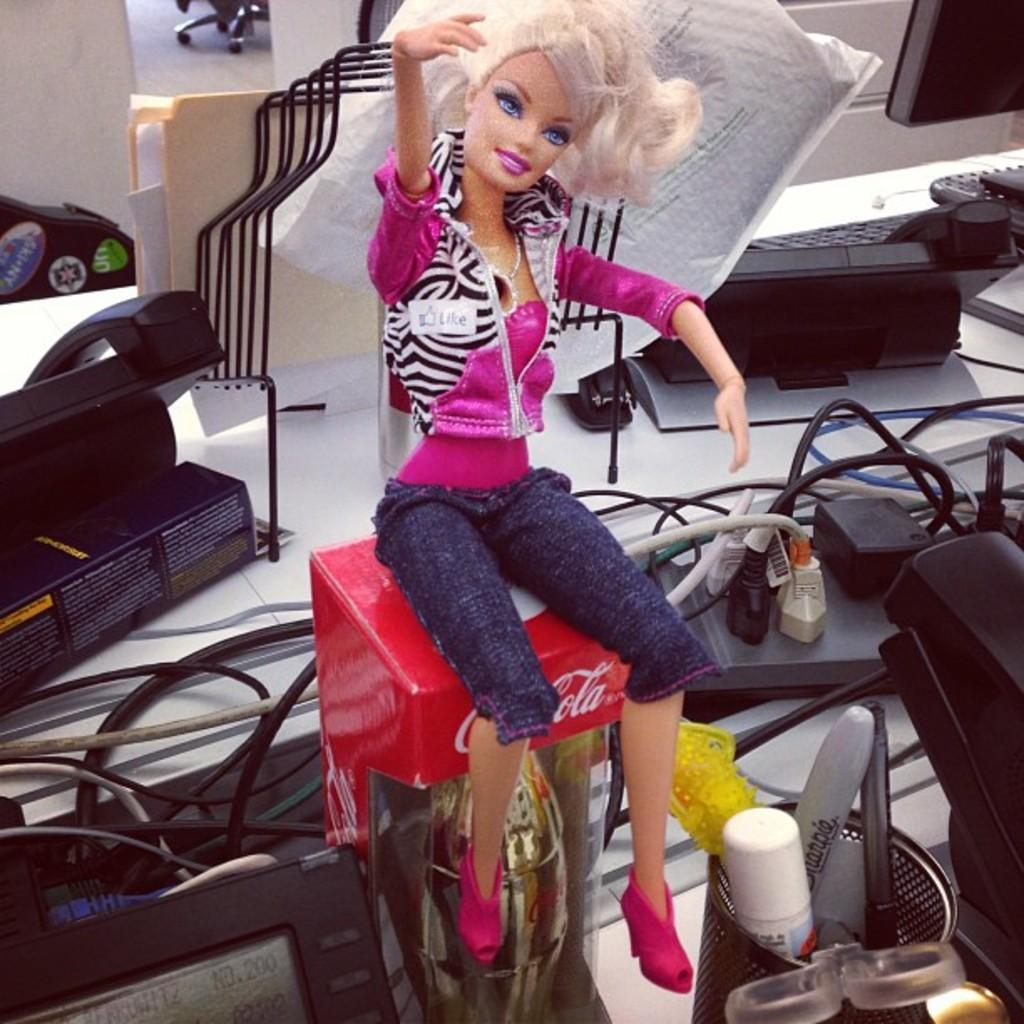What is placed on top of the cake box in the image? There is a barbie doll on a cake box in the image. What type of electrical components can be seen in the image? There are junction boxes in the image. What communication devices are present in the image? There are telephones in the image. What type of display device is visible in the image? There is a monitor in the image. What type of organizational items can be seen in the image? There are files in the image. What other items can be seen on the desk in the image? There are other items on the desk in the image. What color is the desk in the image? The desk is white. What type of swing can be seen in the image? There is no swing present in the image. What rule is being enforced in the image? There is no rule being enforced in the image. 